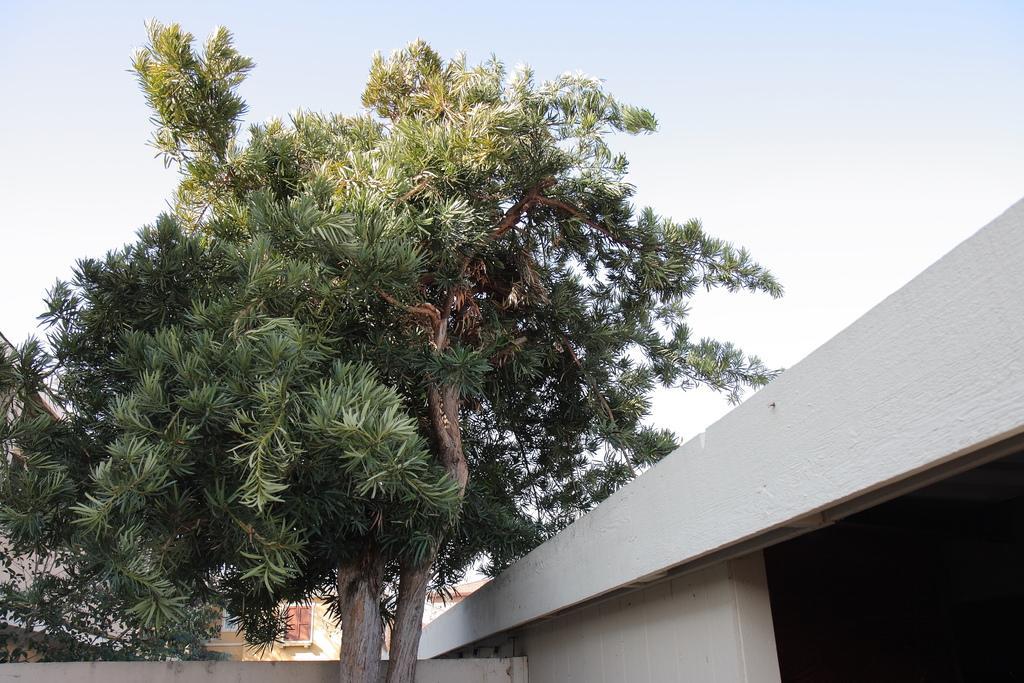How would you summarize this image in a sentence or two? There is house and there are two tall trees in front of the house and behind the trees there is a building and on the left side there are some other plants. 